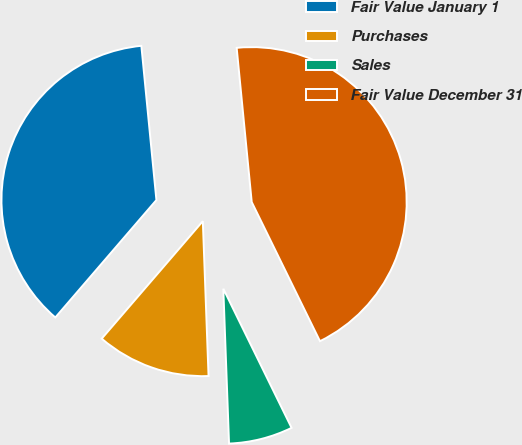<chart> <loc_0><loc_0><loc_500><loc_500><pie_chart><fcel>Fair Value January 1<fcel>Purchases<fcel>Sales<fcel>Fair Value December 31<nl><fcel>37.14%<fcel>11.9%<fcel>6.67%<fcel>44.29%<nl></chart> 